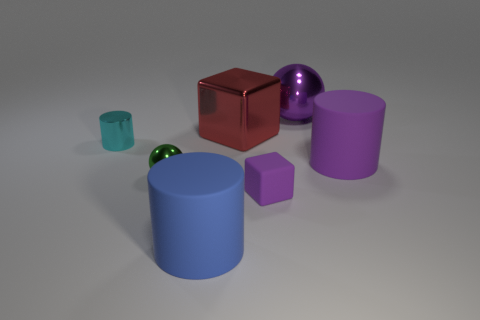What material is the purple object behind the big purple thing on the right side of the large metal thing behind the shiny block?
Provide a succinct answer. Metal. Do the green ball and the purple matte block have the same size?
Your answer should be very brief. Yes. What shape is the thing that is to the left of the blue matte thing and behind the green thing?
Provide a short and direct response. Cylinder. What number of big purple things are the same material as the large red thing?
Offer a terse response. 1. There is a large cylinder to the right of the red metal thing; what number of big purple cylinders are in front of it?
Your response must be concise. 0. What is the shape of the purple object on the left side of the sphere behind the object to the right of the purple sphere?
Your answer should be compact. Cube. There is a matte object that is the same color as the small block; what is its size?
Your answer should be compact. Large. What number of things are tiny blue shiny blocks or big metallic cubes?
Ensure brevity in your answer.  1. What is the color of the ball that is the same size as the metal block?
Make the answer very short. Purple. There is a tiny cyan metallic thing; is it the same shape as the purple matte thing that is behind the small cube?
Your response must be concise. Yes. 